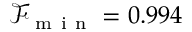Convert formula to latex. <formula><loc_0><loc_0><loc_500><loc_500>\mathcal { F } _ { m i n } = 0 . 9 9 4</formula> 